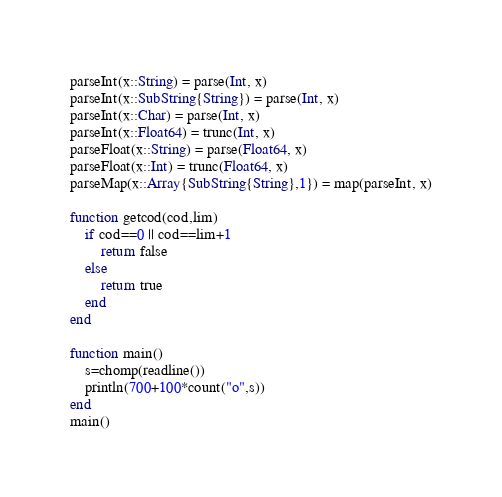<code> <loc_0><loc_0><loc_500><loc_500><_Julia_>parseInt(x::String) = parse(Int, x)
parseInt(x::SubString{String}) = parse(Int, x)
parseInt(x::Char) = parse(Int, x)
parseInt(x::Float64) = trunc(Int, x)
parseFloat(x::String) = parse(Float64, x)
parseFloat(x::Int) = trunc(Float64, x)
parseMap(x::Array{SubString{String},1}) = map(parseInt, x)

function getcod(cod,lim)
    if cod==0 || cod==lim+1
        return false
    else
        return true
    end
end

function main()
    s=chomp(readline())
    println(700+100*count("o",s))
end
main()</code> 